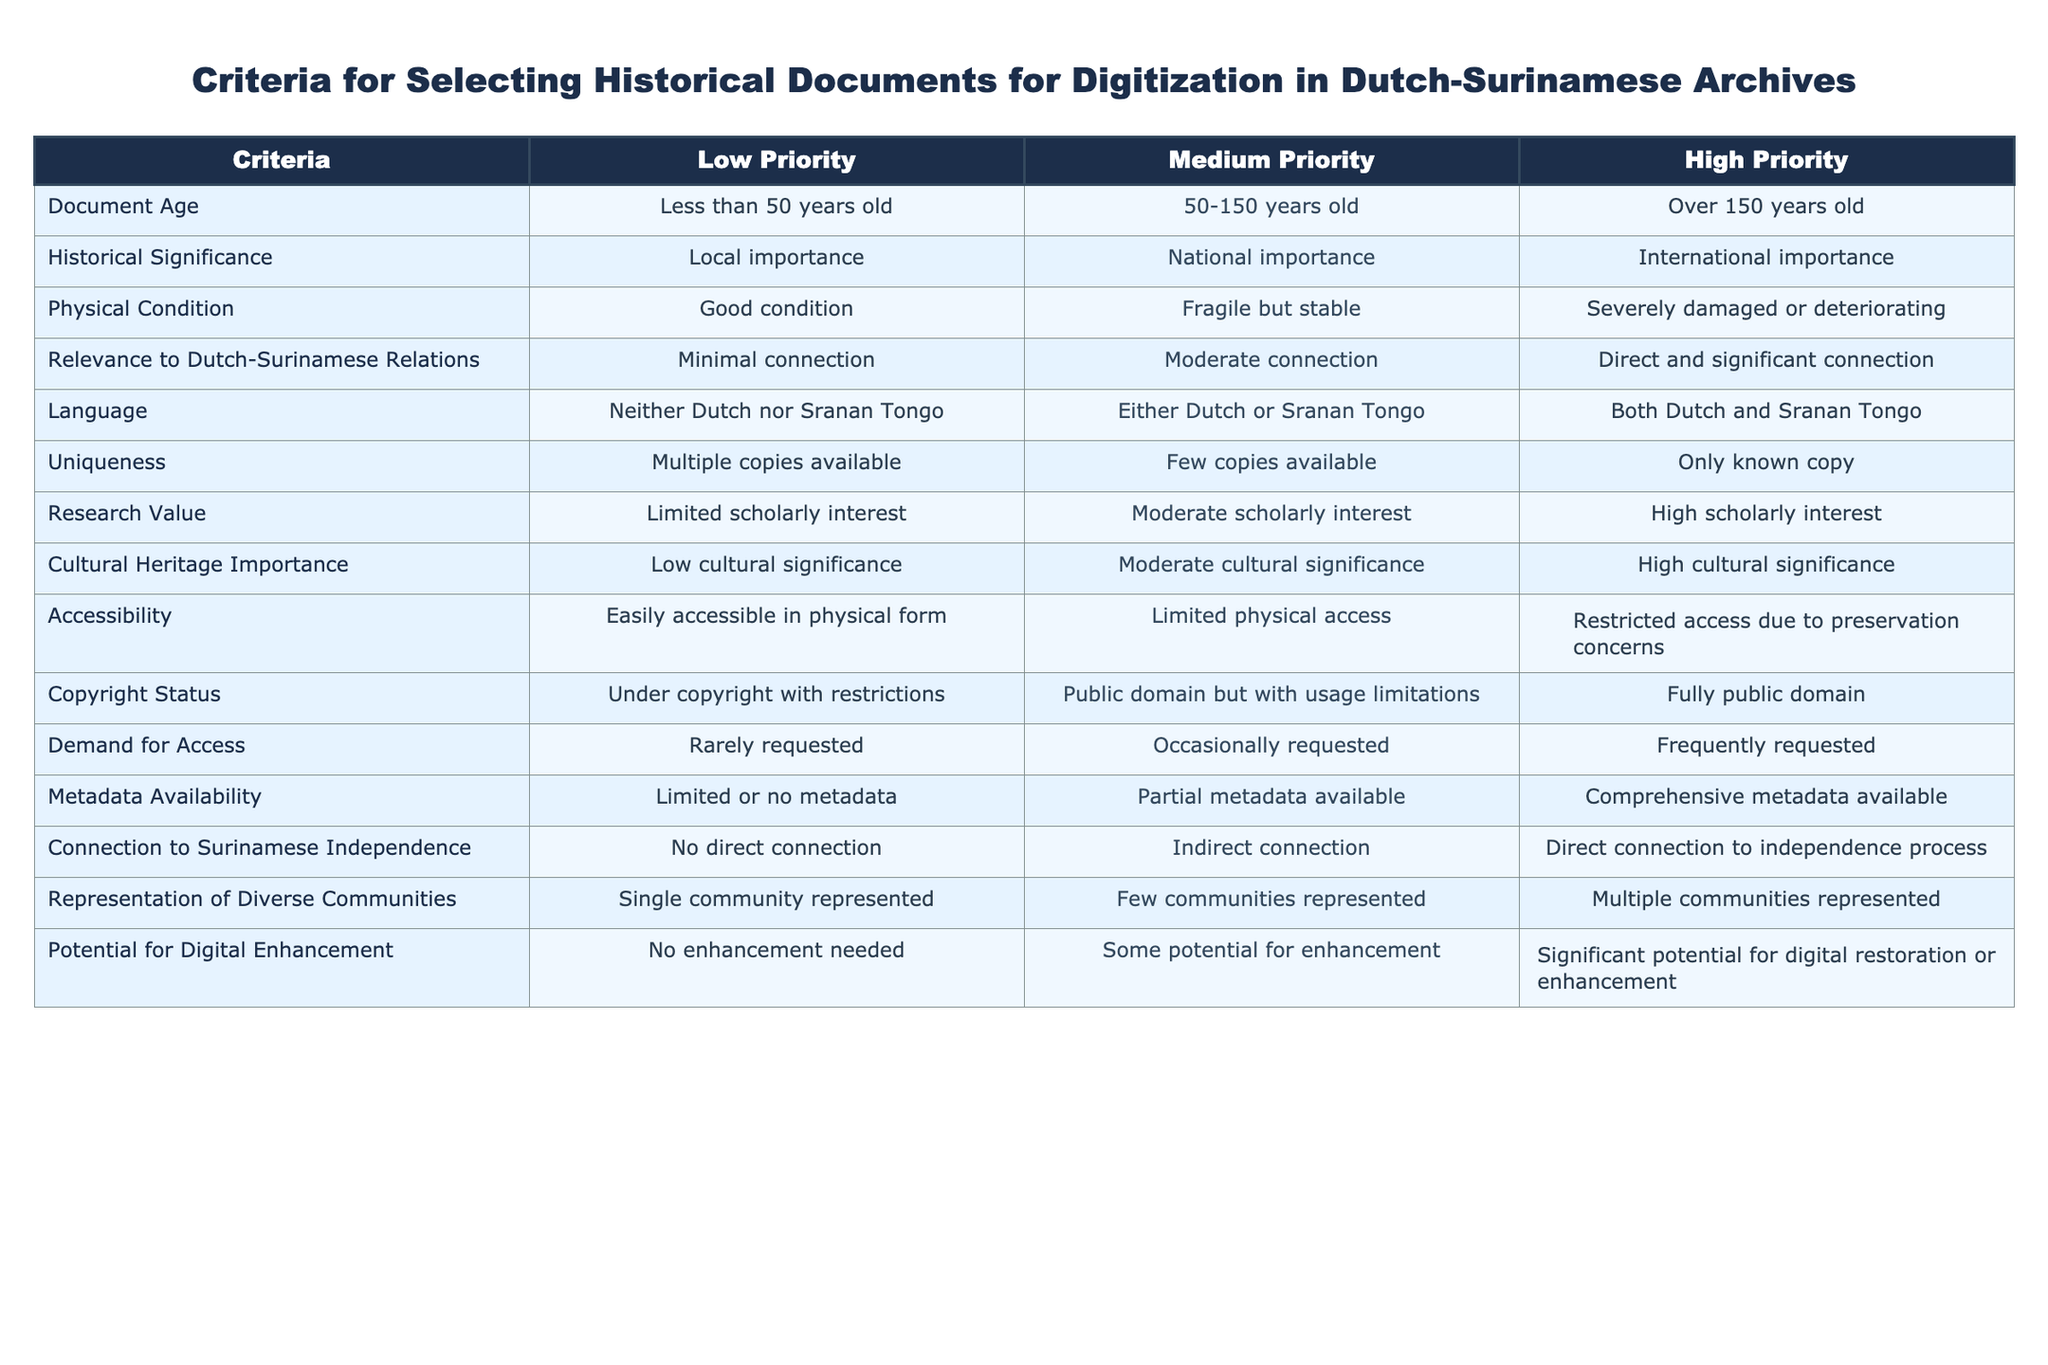What is the highest priority for document age? The highest priority for document age is "Over 150 years old," which is listed under the High Priority column.
Answer: Over 150 years old Is a document in good physical condition considered for high priority digitization? No, a document listed under high priority for physical condition is "Severely damaged or deteriorating," while good condition falls under low priority.
Answer: No How many criteria indicate high cultural significance? There is one criterion related to cultural significance, which is "High cultural significance" under the High Priority column.
Answer: 1 Which language classification would be considered of the highest priority? The highest priority for language classification is "Both Dutch and Sranan Tongo," which is under the High Priority column.
Answer: Both Dutch and Sranan Tongo What is the relationship between physical condition and historical significance in the medium priority category? In the medium priority category, physical condition has "Fragile but stable," while historical significance has "National importance," indicating both criteria are of moderate importance for digitization.
Answer: Fragile but stable and National importance If a document is the only known copy and it is frequently requested, what priority does it fall under for demand for access? It falls under high priority for demand for access, as the response indicates that frequent requests elevate its priority status regardless of other criteria.
Answer: High Priority Can a document with limited scholarly interest be considered for high priority on research value? No, a document with limited scholarly interest cannot be considered high priority, as high priority requires "High scholarly interest."
Answer: No What is the significance of accessibility in determining the priority of documents for digitization? Accessibility that indicates "Restricted access due to preservation concerns" falls under high priority and highlights the urgency in digitization efforts due to accessibility issues.
Answer: High Priority Are documents that contribute to the connection to Surinamese independence considered high priority? Yes, if a document has "Direct connection to independence process," it is categorized as high priority in relation to the theme of Surinamese independence.
Answer: Yes 